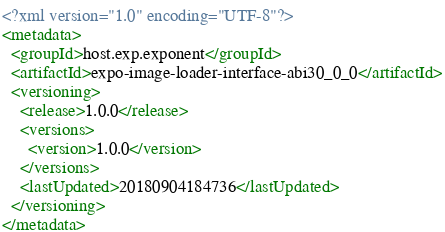<code> <loc_0><loc_0><loc_500><loc_500><_XML_><?xml version="1.0" encoding="UTF-8"?>
<metadata>
  <groupId>host.exp.exponent</groupId>
  <artifactId>expo-image-loader-interface-abi30_0_0</artifactId>
  <versioning>
    <release>1.0.0</release>
    <versions>
      <version>1.0.0</version>
    </versions>
    <lastUpdated>20180904184736</lastUpdated>
  </versioning>
</metadata>
</code> 